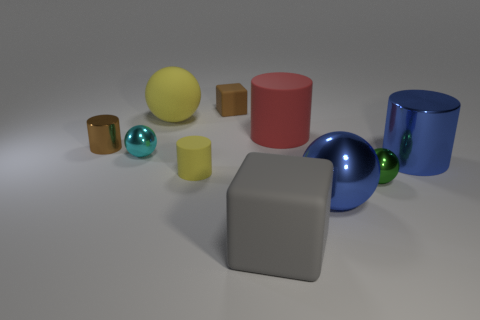Are there more brown rubber blocks to the right of the tiny brown shiny thing than tiny cyan metal objects that are in front of the blue metallic ball?
Your answer should be very brief. Yes. Does the rubber block behind the blue metallic cylinder have the same color as the tiny metal cylinder?
Give a very brief answer. Yes. What size is the brown block?
Your answer should be compact. Small. There is a red cylinder that is the same size as the rubber ball; what is it made of?
Your answer should be compact. Rubber. What is the color of the metallic ball on the left side of the small brown matte thing?
Give a very brief answer. Cyan. How many green shiny cylinders are there?
Your response must be concise. 0. Are there any small brown objects behind the small metal thing that is behind the tiny sphere that is on the left side of the big matte block?
Your answer should be very brief. Yes. There is a gray thing that is the same size as the red rubber cylinder; what shape is it?
Make the answer very short. Cube. What number of other objects are there of the same color as the tiny matte cylinder?
Provide a succinct answer. 1. What material is the tiny yellow thing?
Ensure brevity in your answer.  Rubber. 